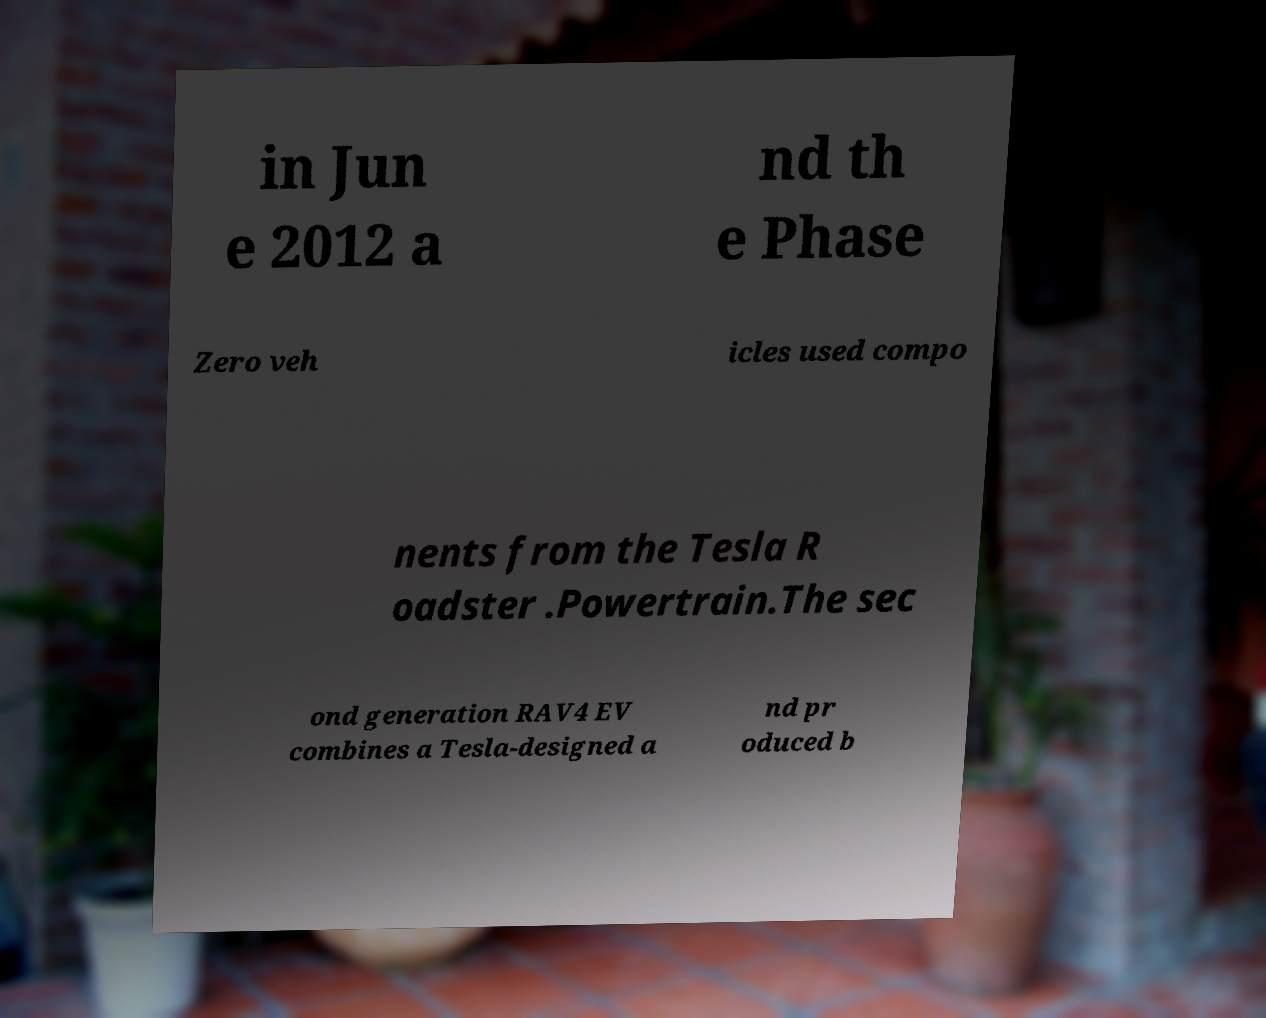There's text embedded in this image that I need extracted. Can you transcribe it verbatim? in Jun e 2012 a nd th e Phase Zero veh icles used compo nents from the Tesla R oadster .Powertrain.The sec ond generation RAV4 EV combines a Tesla-designed a nd pr oduced b 